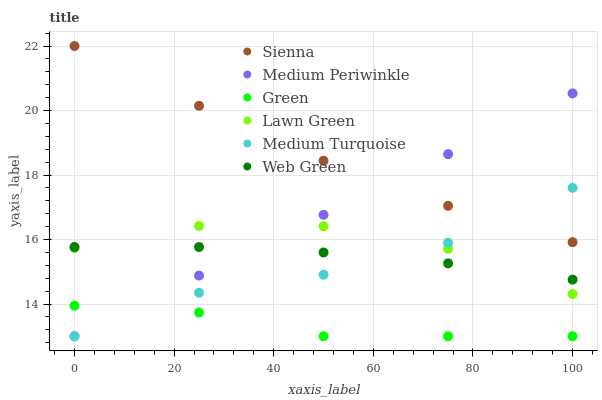Does Green have the minimum area under the curve?
Answer yes or no. Yes. Does Sienna have the maximum area under the curve?
Answer yes or no. Yes. Does Medium Periwinkle have the minimum area under the curve?
Answer yes or no. No. Does Medium Periwinkle have the maximum area under the curve?
Answer yes or no. No. Is Medium Periwinkle the smoothest?
Answer yes or no. Yes. Is Lawn Green the roughest?
Answer yes or no. Yes. Is Web Green the smoothest?
Answer yes or no. No. Is Web Green the roughest?
Answer yes or no. No. Does Medium Periwinkle have the lowest value?
Answer yes or no. Yes. Does Web Green have the lowest value?
Answer yes or no. No. Does Sienna have the highest value?
Answer yes or no. Yes. Does Medium Periwinkle have the highest value?
Answer yes or no. No. Is Green less than Sienna?
Answer yes or no. Yes. Is Lawn Green greater than Green?
Answer yes or no. Yes. Does Medium Turquoise intersect Sienna?
Answer yes or no. Yes. Is Medium Turquoise less than Sienna?
Answer yes or no. No. Is Medium Turquoise greater than Sienna?
Answer yes or no. No. Does Green intersect Sienna?
Answer yes or no. No. 